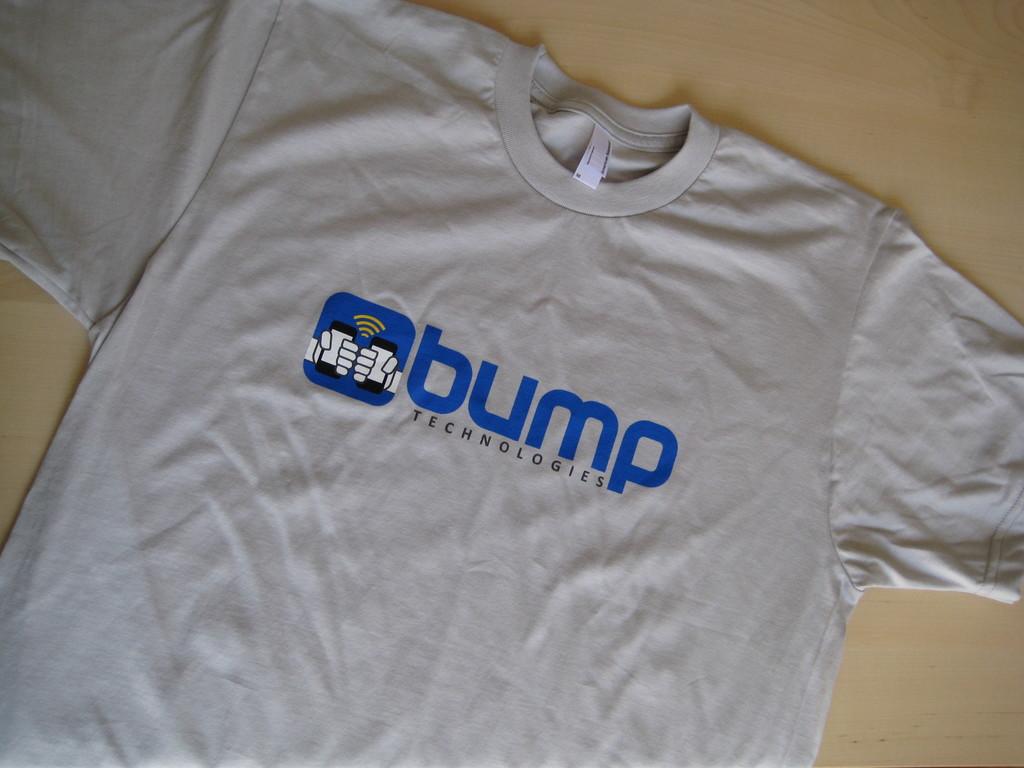What technology brand is on the shirty?
Your answer should be compact. Bump. What color is the text?
Ensure brevity in your answer.  Answering does not require reading text in the image. 